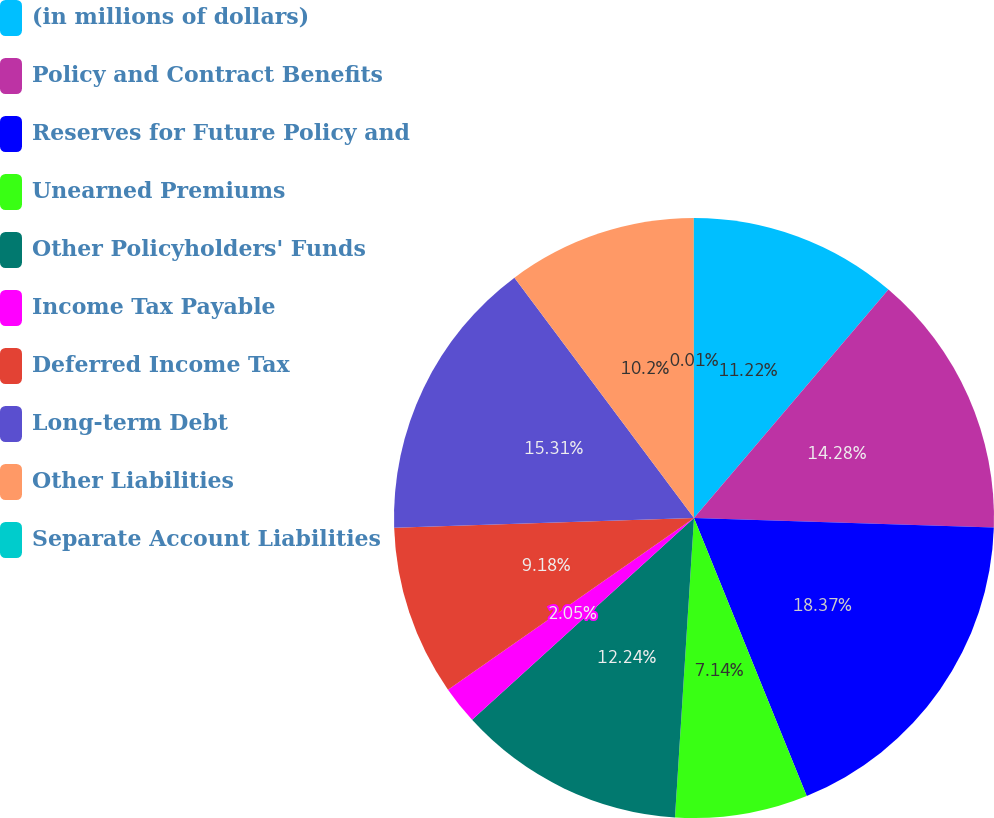<chart> <loc_0><loc_0><loc_500><loc_500><pie_chart><fcel>(in millions of dollars)<fcel>Policy and Contract Benefits<fcel>Reserves for Future Policy and<fcel>Unearned Premiums<fcel>Other Policyholders' Funds<fcel>Income Tax Payable<fcel>Deferred Income Tax<fcel>Long-term Debt<fcel>Other Liabilities<fcel>Separate Account Liabilities<nl><fcel>11.22%<fcel>14.28%<fcel>18.36%<fcel>7.14%<fcel>12.24%<fcel>2.05%<fcel>9.18%<fcel>15.3%<fcel>10.2%<fcel>0.01%<nl></chart> 